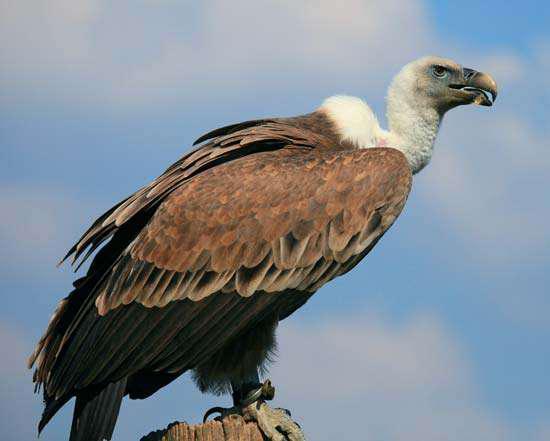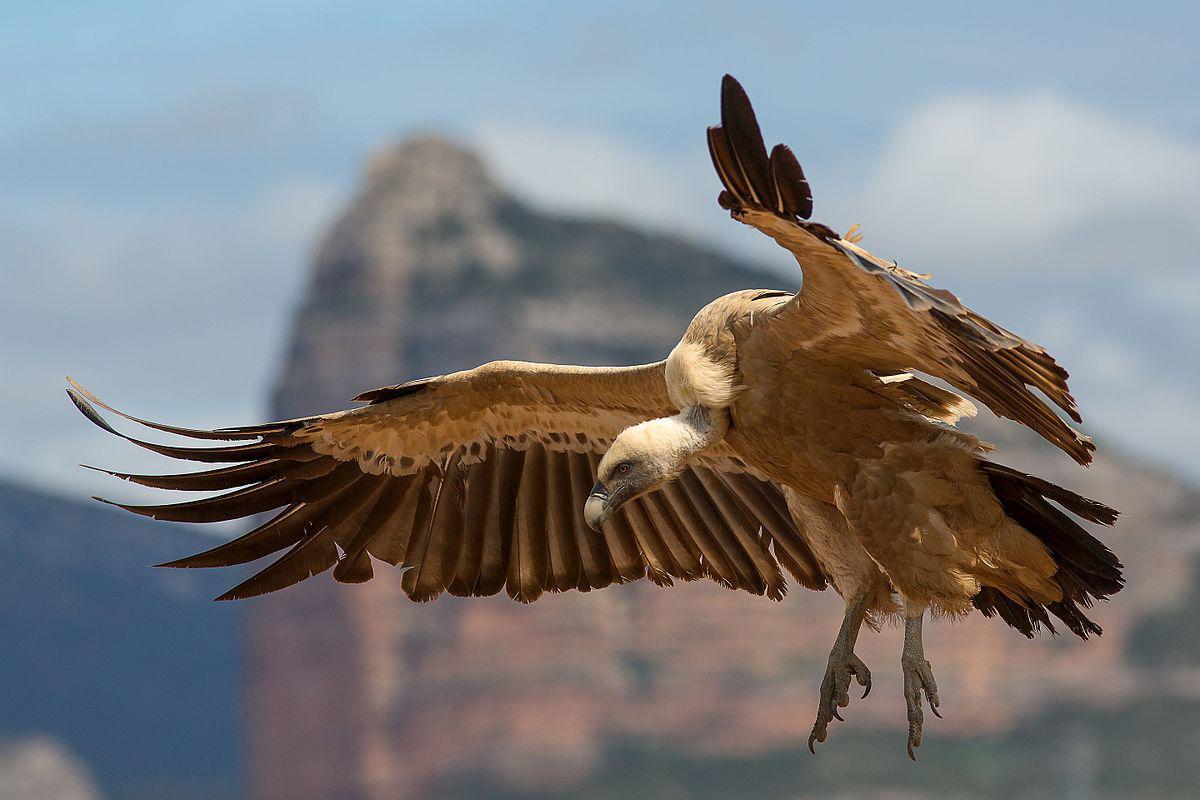The first image is the image on the left, the second image is the image on the right. Examine the images to the left and right. Is the description "The left and right image contains the same vultures." accurate? Answer yes or no. Yes. The first image is the image on the left, the second image is the image on the right. For the images shown, is this caption "One image shows a white-headed vulture in flight with its wings spread." true? Answer yes or no. Yes. 